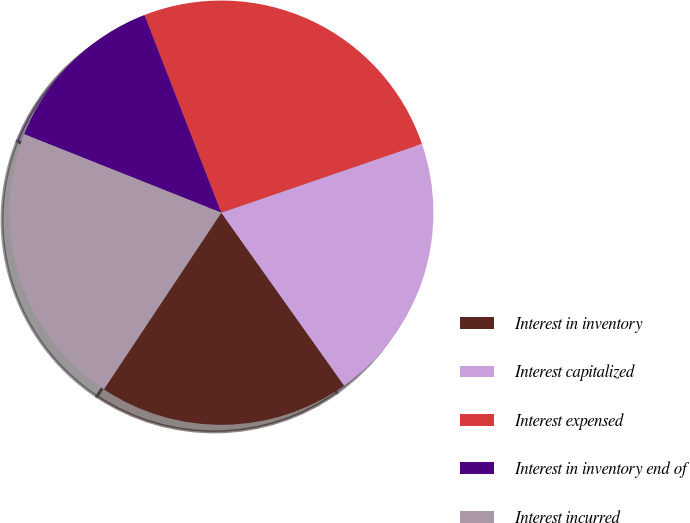Convert chart. <chart><loc_0><loc_0><loc_500><loc_500><pie_chart><fcel>Interest in inventory<fcel>Interest capitalized<fcel>Interest expensed<fcel>Interest in inventory end of<fcel>Interest incurred<nl><fcel>19.17%<fcel>20.43%<fcel>25.64%<fcel>13.07%<fcel>21.69%<nl></chart> 